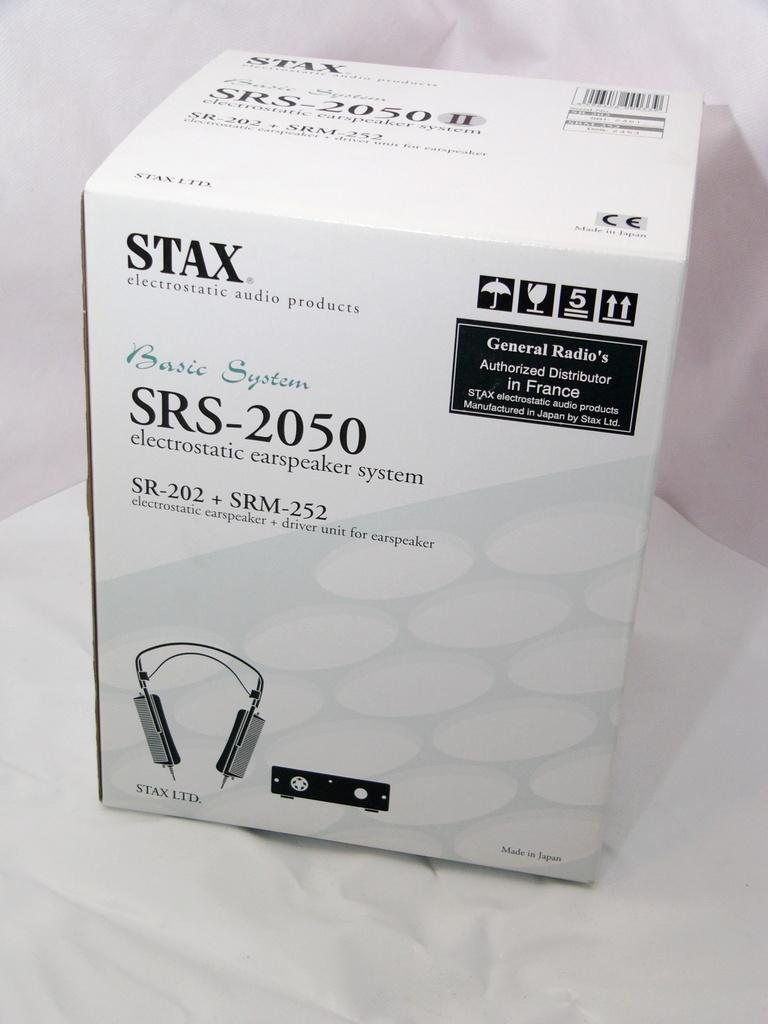<image>
Relay a brief, clear account of the picture shown. A box from Stax electrostatic audio products with electrostatic earspeaker system in the box. 